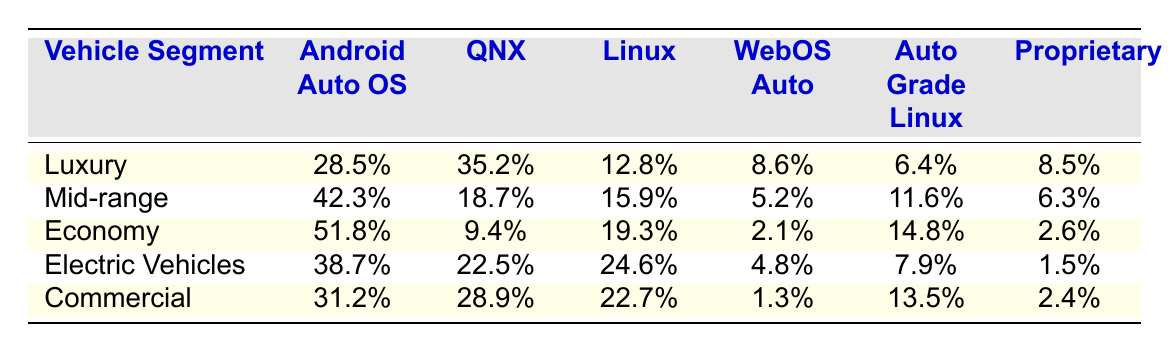What is the market share of Android Automotive OS in the Economy segment? According to the table, Android Automotive OS has a market share of 51.8% in the Economy segment.
Answer: 51.8% Which vehicle segment has the highest market share for QNX? In the table, it shows that the Luxury segment has the highest market share for QNX at 35.2%.
Answer: Luxury What is the total market share percentage for Linux across all vehicle segments? The total for Linux is calculated by summing the values: 12.8 + 15.9 + 19.3 + 24.6 + 22.7 = 95.3%.
Answer: 95.3% Does the Automotive Grade Linux have a higher market share in the Mid-range segment compared to the Commercial segment? The table shows that Automotive Grade Linux has 11.6% in Mid-range, while in Commercial, it has 13.5%, thus it is lower in Mid-range.
Answer: No What is the average market share of WebOS Auto across all vehicle segments? The average for WebOS Auto is calculated by summing the values: 8.6 + 5.2 + 2.1 + 4.8 + 1.3 = 22.0%, then dividing by 5 segments gives 22.0 / 5 = 4.4%.
Answer: 4.4% In which vehicle segment does Proprietary Systems have the lowest market share? Looking at the table, Proprietary Systems has the lowest market share of 1.3% in the Commercial segment.
Answer: Commercial Which operating system has a market share difference of more than 10% between the Luxury and Economy segments? The operating system Android Automotive OS has a difference of 23.3% (51.8% - 28.5%) between the Economy and Luxury segments.
Answer: Android Automotive OS What percentage of Electric Vehicles uses QNX compared to Proprietary Systems? For Electric Vehicles, QNX has 22.5% and Proprietary Systems has 1.5%, so the difference is 22.5% - 1.5% = 21%.
Answer: 21% Which operating system is most common in the Mid-range segment? Based on the table, Android Automotive OS is the most common in the Mid-range segment with a market share of 42.3%.
Answer: Android Automotive OS 